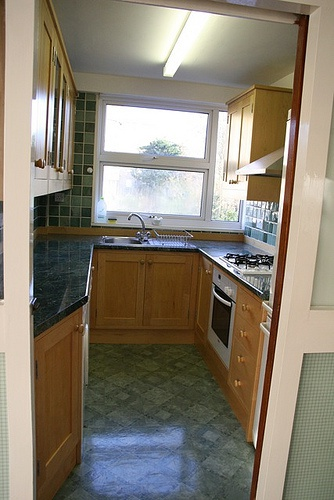Describe the objects in this image and their specific colors. I can see oven in black, gray, and darkgray tones, sink in black, darkgray, and gray tones, and refrigerator in black, white, darkgray, tan, and gray tones in this image. 